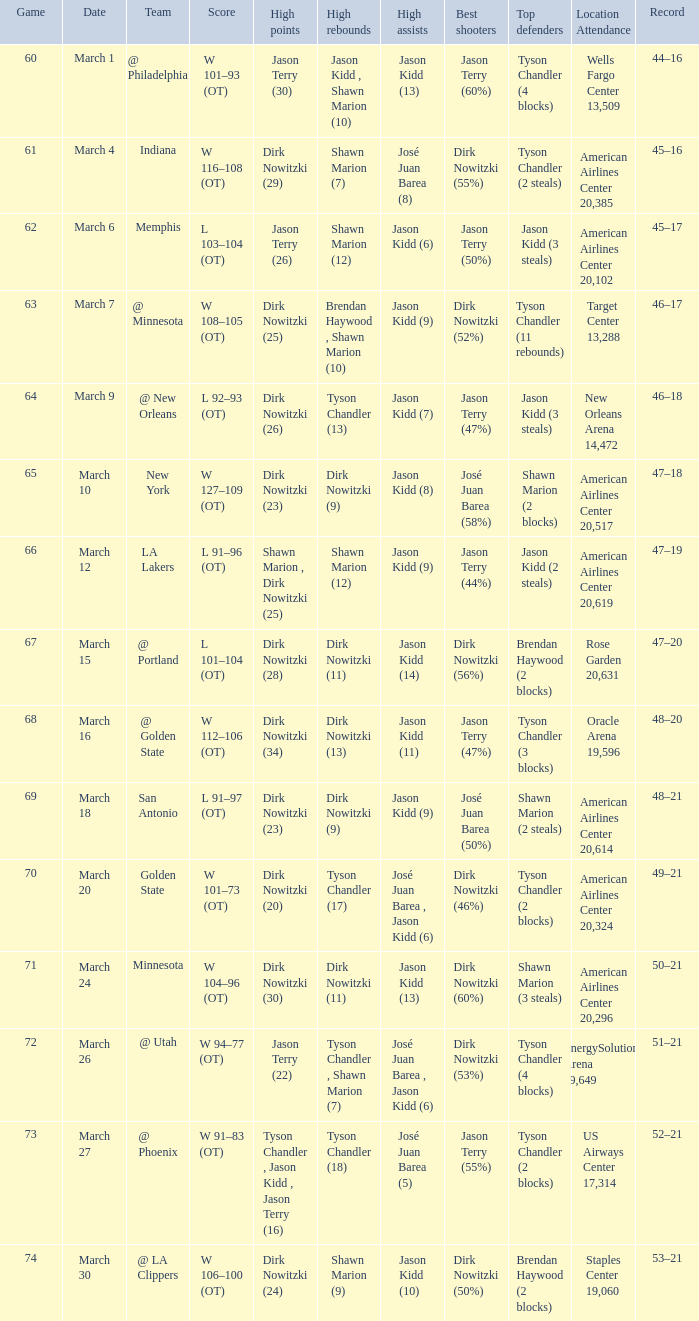Name the score for  josé juan barea (8) W 116–108 (OT). 